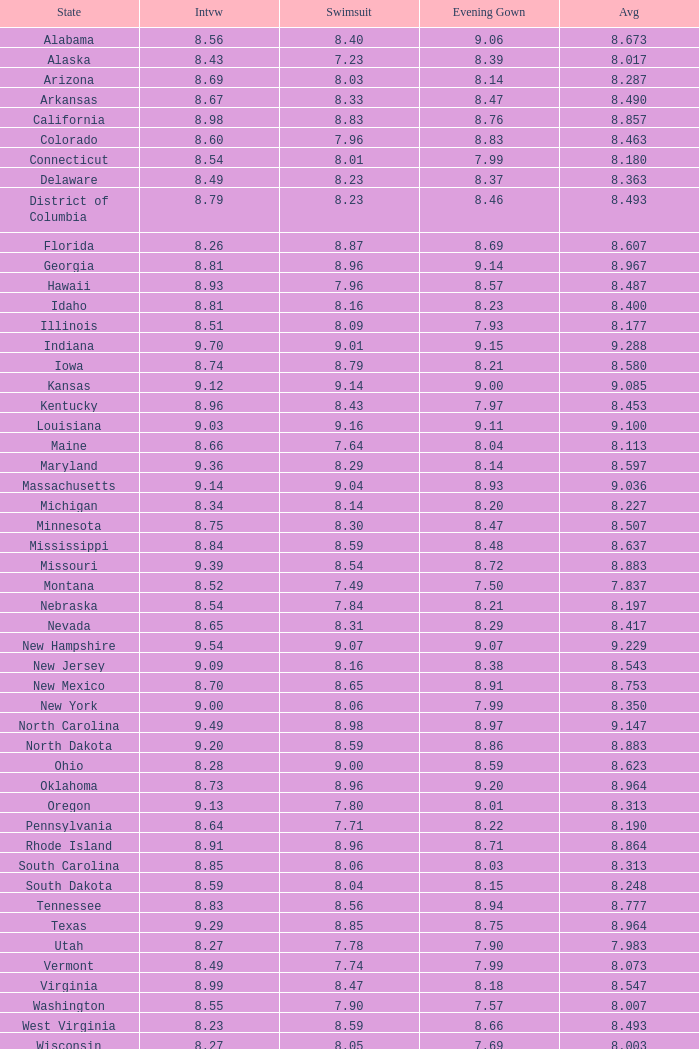Name the state with an evening gown more than 8.86 and interview less than 8.7 and swimsuit less than 8.96 Alabama. 